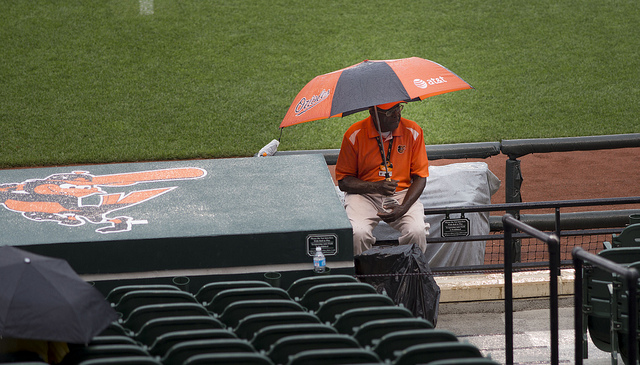What is the weather like in this scene? The weather appears to be rainy, as evidenced by the person using an umbrella and the wet surfaces around the seating area. 